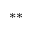Convert formula to latex. <formula><loc_0><loc_0><loc_500><loc_500>^ { * * }</formula> 